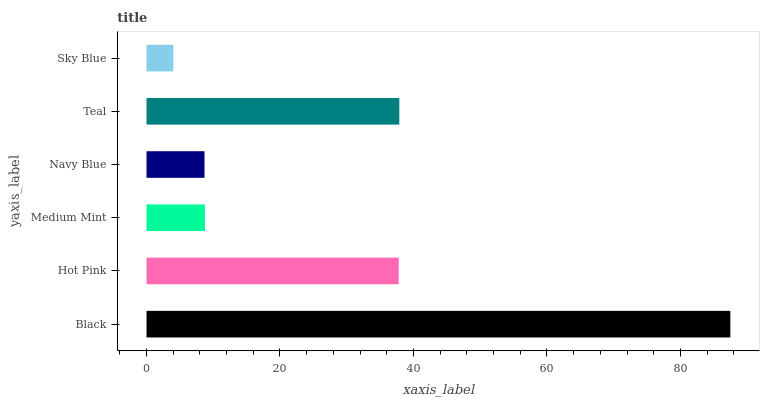Is Sky Blue the minimum?
Answer yes or no. Yes. Is Black the maximum?
Answer yes or no. Yes. Is Hot Pink the minimum?
Answer yes or no. No. Is Hot Pink the maximum?
Answer yes or no. No. Is Black greater than Hot Pink?
Answer yes or no. Yes. Is Hot Pink less than Black?
Answer yes or no. Yes. Is Hot Pink greater than Black?
Answer yes or no. No. Is Black less than Hot Pink?
Answer yes or no. No. Is Hot Pink the high median?
Answer yes or no. Yes. Is Medium Mint the low median?
Answer yes or no. Yes. Is Medium Mint the high median?
Answer yes or no. No. Is Hot Pink the low median?
Answer yes or no. No. 